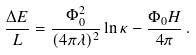Convert formula to latex. <formula><loc_0><loc_0><loc_500><loc_500>\frac { \Delta E } { L } = \frac { \Phi _ { 0 } ^ { 2 } } { ( { 4 \pi \lambda } ) ^ { 2 } } \ln \kappa - \frac { \Phi _ { 0 } H } { 4 \pi } \, .</formula> 